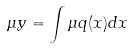<formula> <loc_0><loc_0><loc_500><loc_500>\mu y = \int \mu q ( x ) d x</formula> 